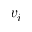<formula> <loc_0><loc_0><loc_500><loc_500>v _ { i }</formula> 